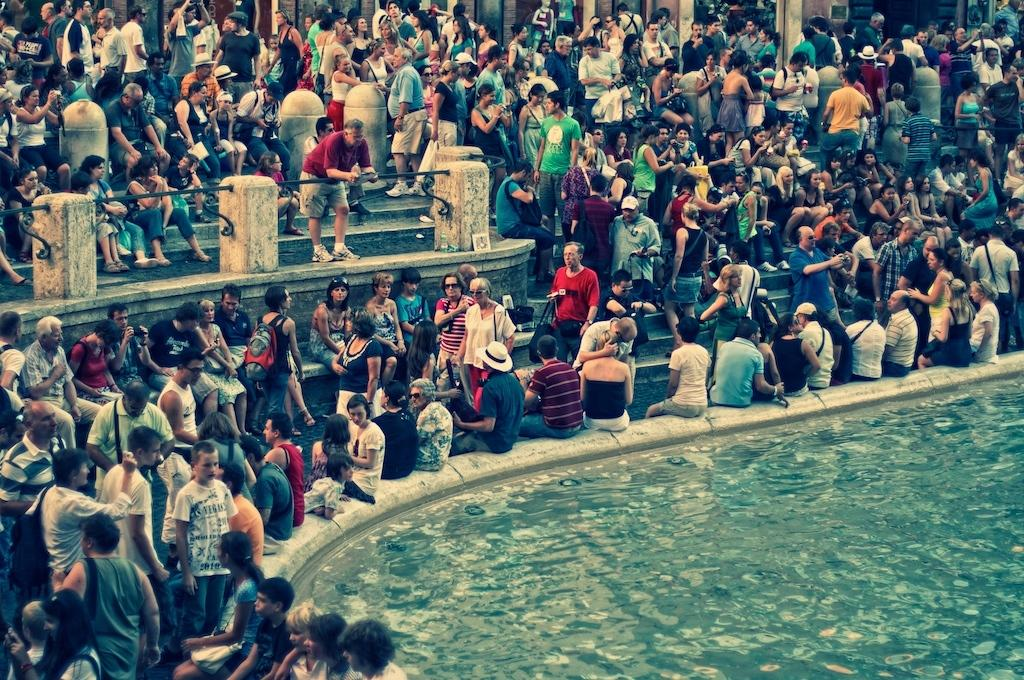How many people are in the image? There are a few people in the image. What structures can be seen in the image? There is a fence, stairs, and a wall in the image. What natural element is visible in the image? There is water visible in the image. What type of steel is used to construct the donkey in the image? There is no donkey present in the image, and therefore no steel construction can be observed. Additionally, steel is not typically used to construct animals. 